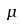Convert formula to latex. <formula><loc_0><loc_0><loc_500><loc_500>\mu</formula> 